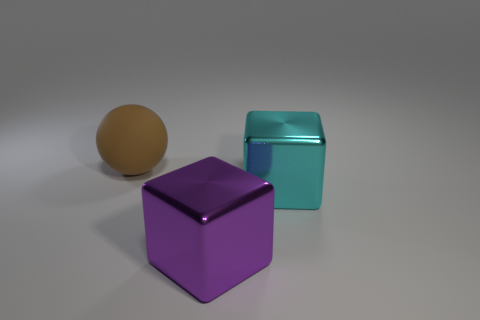Subtract 1 blocks. How many blocks are left? 1 Add 2 gray blocks. How many objects exist? 5 Subtract all purple cubes. How many cubes are left? 1 Subtract all brown blocks. Subtract all gray cylinders. How many blocks are left? 2 Subtract all yellow cylinders. How many cyan blocks are left? 1 Subtract all big gray cubes. Subtract all big matte objects. How many objects are left? 2 Add 3 big brown objects. How many big brown objects are left? 4 Add 2 large shiny cubes. How many large shiny cubes exist? 4 Subtract 0 red cylinders. How many objects are left? 3 Subtract all blocks. How many objects are left? 1 